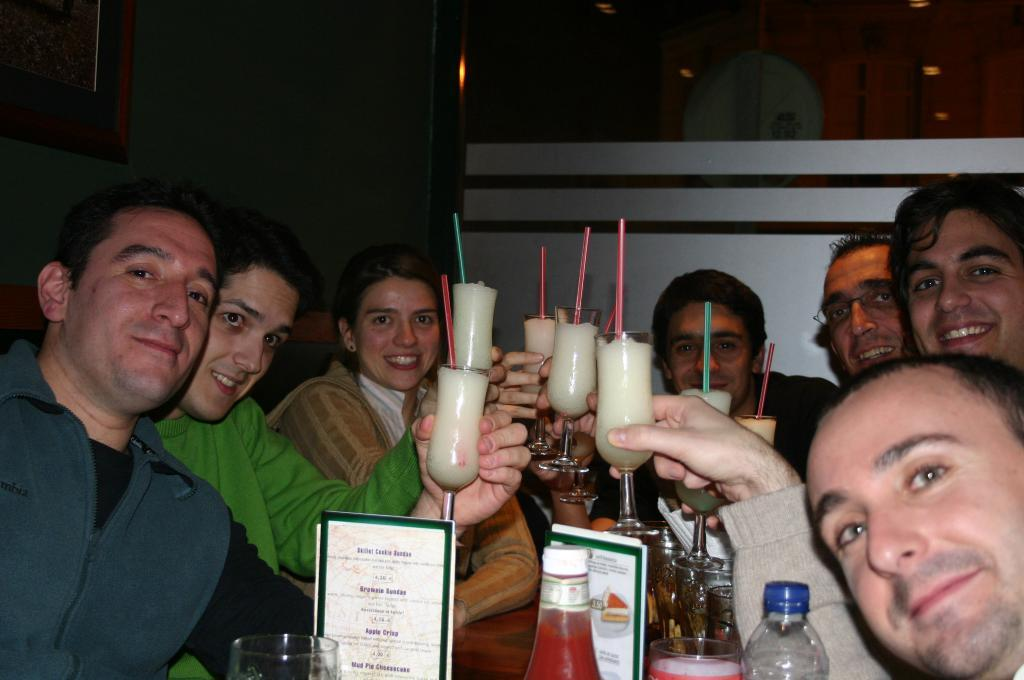What is happening in the image involving the group of people? The people in the image are holding glasses of juice. What might be the source of the juice in the image? The bottles present in front of the people might be the source of the juice. Reasoning: Let's think step by step by step in order to produce the conversation. We start by identifying the main subject in the image, which is the group of people. Then, we expand the conversation to include the action of the people, which is holding glasses of juice. Finally, we mention the bottles present in front of the people, which might be related to the juice. Absurd Question/Answer: What type of prose can be heard being read aloud in the image? There is no indication of any prose being read aloud in the image. Can you describe the smiles on the faces of the people in the image? The provided facts do not mention any smiles on the faces of the people in the image. What type of sound can be heard coming from the bottles in the image? There is no indication of any sound coming from the bottles in the image. 